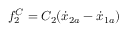Convert formula to latex. <formula><loc_0><loc_0><loc_500><loc_500>f _ { 2 } ^ { C } = C _ { 2 } ( \dot { x } _ { 2 a } - \dot { x } _ { 1 a } )</formula> 